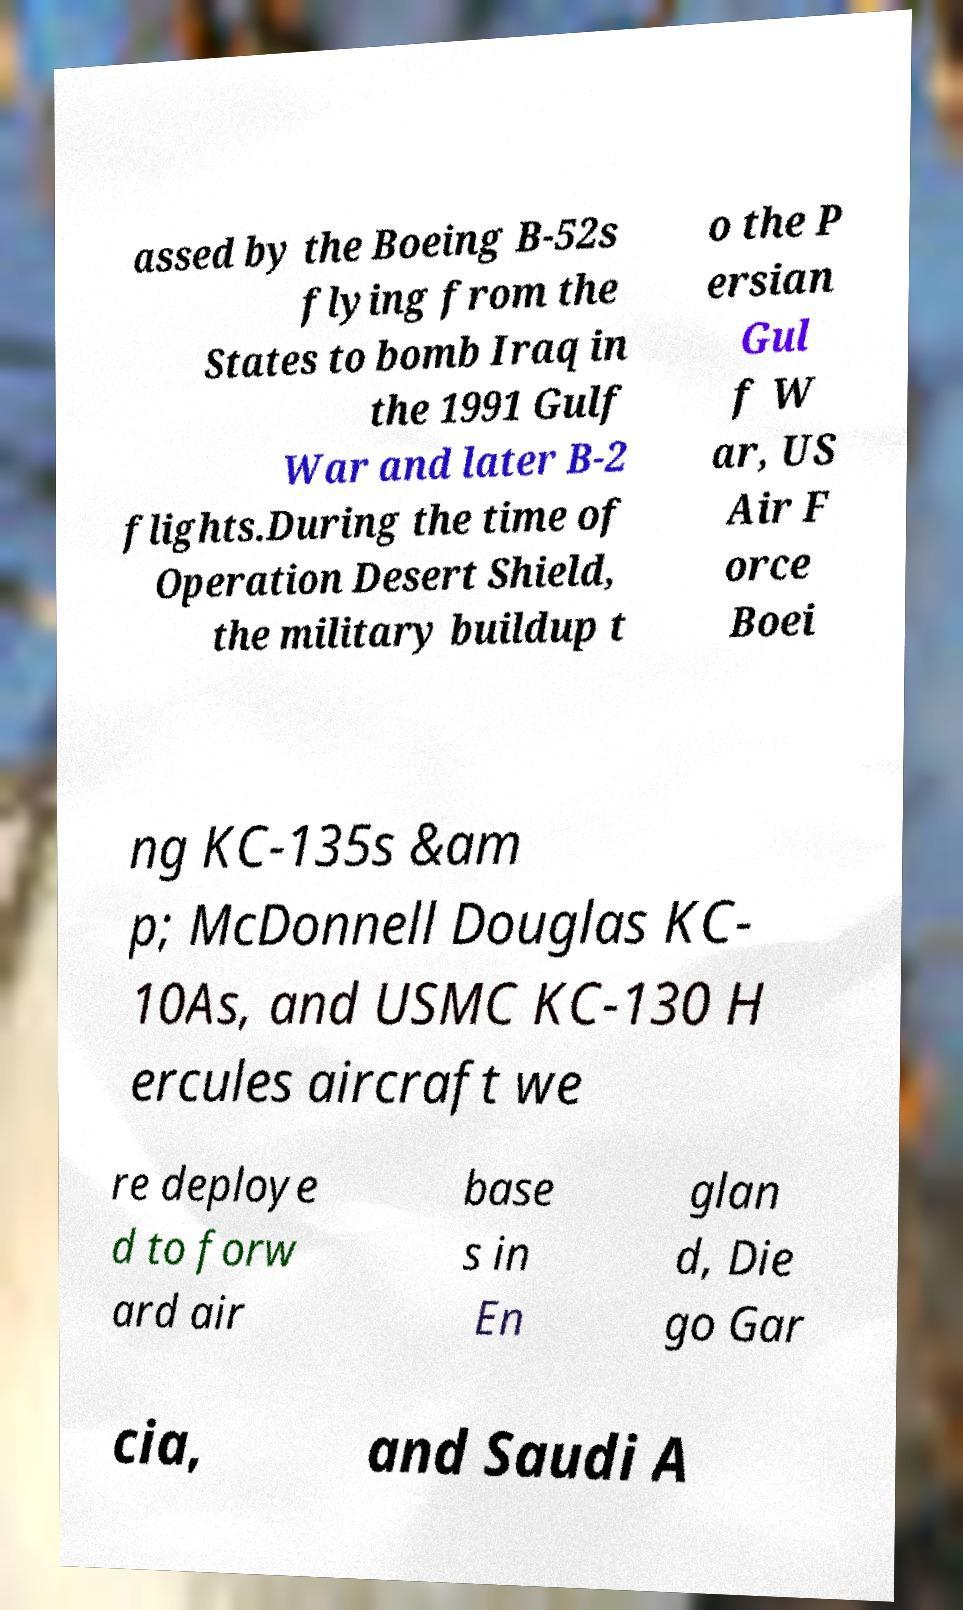There's text embedded in this image that I need extracted. Can you transcribe it verbatim? assed by the Boeing B-52s flying from the States to bomb Iraq in the 1991 Gulf War and later B-2 flights.During the time of Operation Desert Shield, the military buildup t o the P ersian Gul f W ar, US Air F orce Boei ng KC-135s &am p; McDonnell Douglas KC- 10As, and USMC KC-130 H ercules aircraft we re deploye d to forw ard air base s in En glan d, Die go Gar cia, and Saudi A 